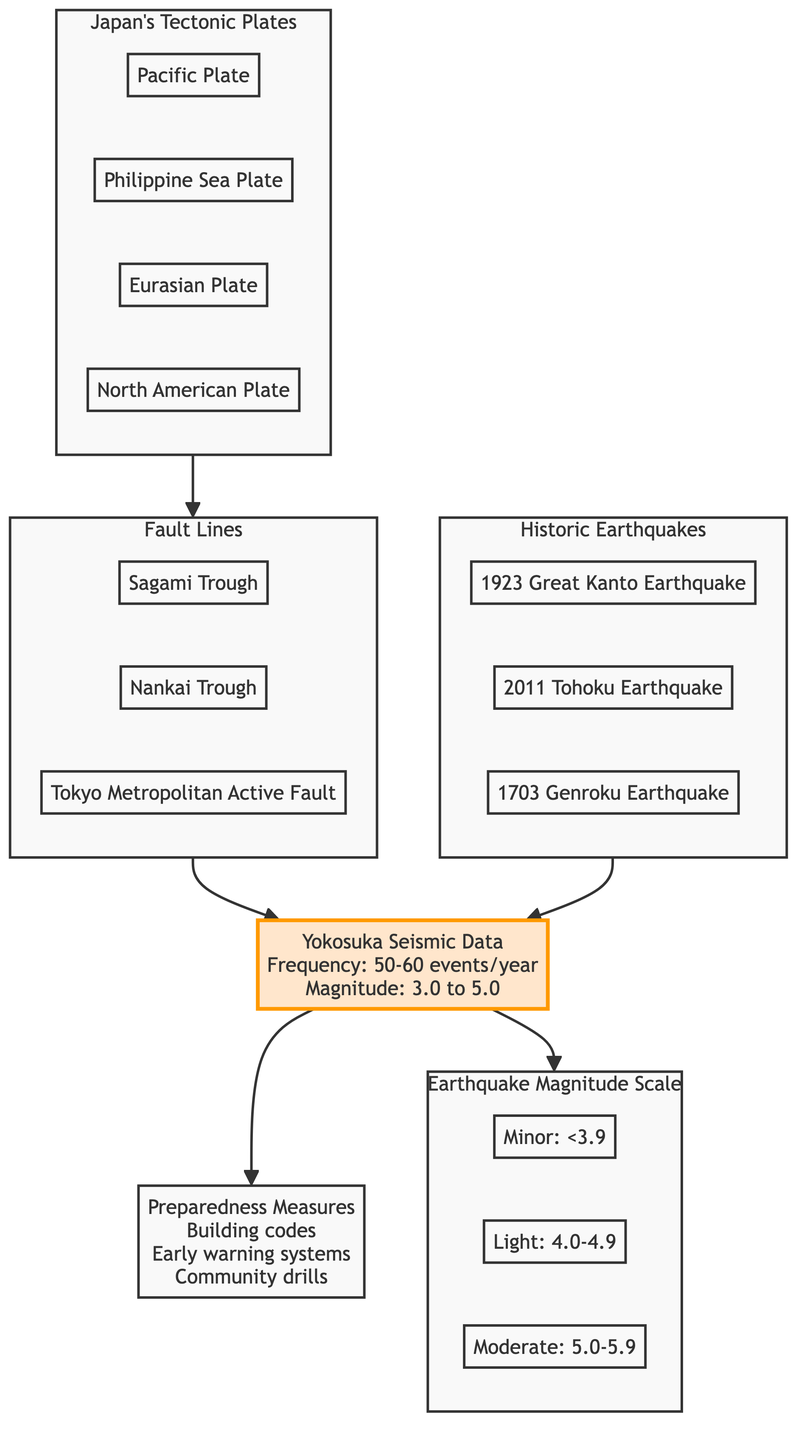What is the frequency of seismic events in Yokosuka? According to the diagram, the frequency of seismic events in Yokosuka is indicated as 50-60 events per year. This is shown in the highlighted node labeled "Yokosuka Seismic Data."
Answer: 50-60 events/year Which tectonic plate is located to the east of Japan? The Pacific Plate is depicted in the subgraph titled "Japan's Tectonic Plates" and is located to the east, contributing to seismic activity.
Answer: Pacific Plate What is the range of magnitudes for earthquakes in Yokosuka? The diagram specifies that earthquakes in the Yokosuka region have magnitudes ranging from 3.0 to 5.0, discussed in the node labeled "Yokosuka Seismic Data."
Answer: 3.0 to 5.0 How many historic earthquakes are represented in the diagram? The "Historic Earthquakes" subgraph shows three significant earthquakes: the 1923 Great Kanto Earthquake, the 2011 Tohoku Earthquake, and the 1703 Genroku Earthquake. Thus, there are three historic earthquakes listed.
Answer: 3 Which fault line is associated with the Tokyo metropolitan area? The diagram contains a node labeled "Tokyo Metropolitan Active Fault" within the "Fault Lines" subgraph, establishing its association with the Tokyo metropolitan area.
Answer: Tokyo Metropolitan Active Fault What preparedness measures are mentioned in the diagram? The preparedness measures are outlined in a node labeled "Preparedness Measures," which includes building codes, early warning systems, and community drills. This comprehensive approach to preparedness is essential for seismic safety.
Answer: Building codes, early warning systems, community drills Which earthquake had the highest magnitude based on historical data? Looking at the historic earthquakes depicted, while the diagram doesn't explicitly list their magnitudes, historical context indicates that the 2011 Tohoku Earthquake is known to have had significant magnitude (at least 9.0). Therefore, it can be inferred as the highest magnitude earthquake represented.
Answer: 2011 Tohoku Earthquake What are the three severity categories for earthquake magnitudes mentioned? The "Earthquake Magnitude Scale" subgraph lists severities: Minor (<3.9), Light (4.0-4.9), and Moderate (5.0-5.9). This categorization helps in understanding the potential impact of earthquakes.
Answer: Minor, Light, Moderate 